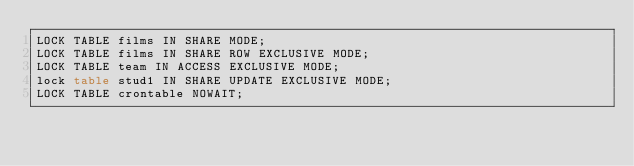Convert code to text. <code><loc_0><loc_0><loc_500><loc_500><_SQL_>LOCK TABLE films IN SHARE MODE;
LOCK TABLE films IN SHARE ROW EXCLUSIVE MODE;
LOCK TABLE team IN ACCESS EXCLUSIVE MODE;
lock table stud1 IN SHARE UPDATE EXCLUSIVE MODE;
LOCK TABLE crontable NOWAIT;
</code> 